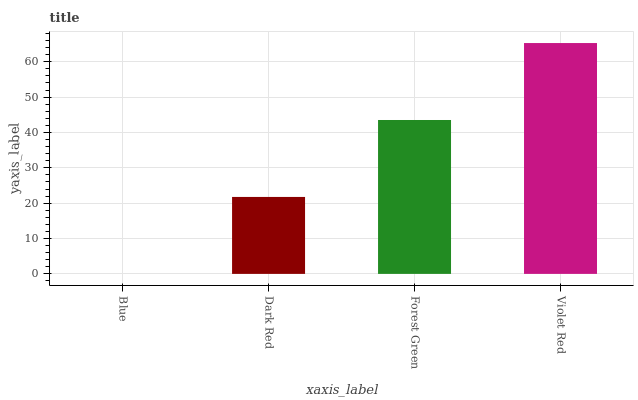Is Blue the minimum?
Answer yes or no. Yes. Is Violet Red the maximum?
Answer yes or no. Yes. Is Dark Red the minimum?
Answer yes or no. No. Is Dark Red the maximum?
Answer yes or no. No. Is Dark Red greater than Blue?
Answer yes or no. Yes. Is Blue less than Dark Red?
Answer yes or no. Yes. Is Blue greater than Dark Red?
Answer yes or no. No. Is Dark Red less than Blue?
Answer yes or no. No. Is Forest Green the high median?
Answer yes or no. Yes. Is Dark Red the low median?
Answer yes or no. Yes. Is Blue the high median?
Answer yes or no. No. Is Violet Red the low median?
Answer yes or no. No. 